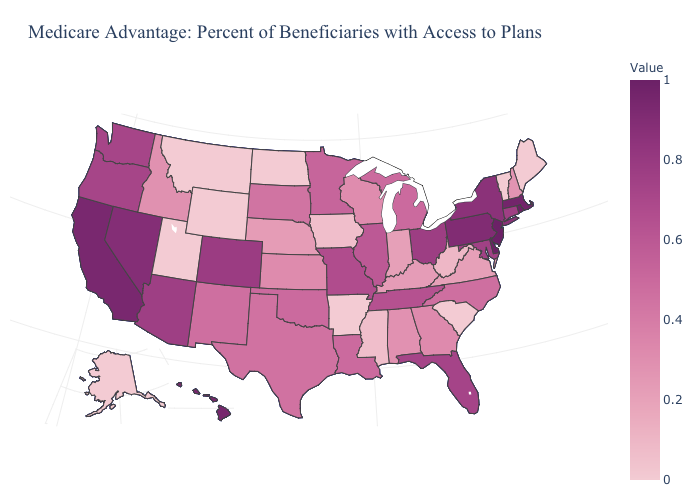Among the states that border California , which have the lowest value?
Keep it brief. Oregon. Does Alaska have the highest value in the West?
Be succinct. No. Is the legend a continuous bar?
Concise answer only. Yes. Does North Dakota have the lowest value in the MidWest?
Write a very short answer. Yes. Does Illinois have a lower value than Delaware?
Short answer required. Yes. 